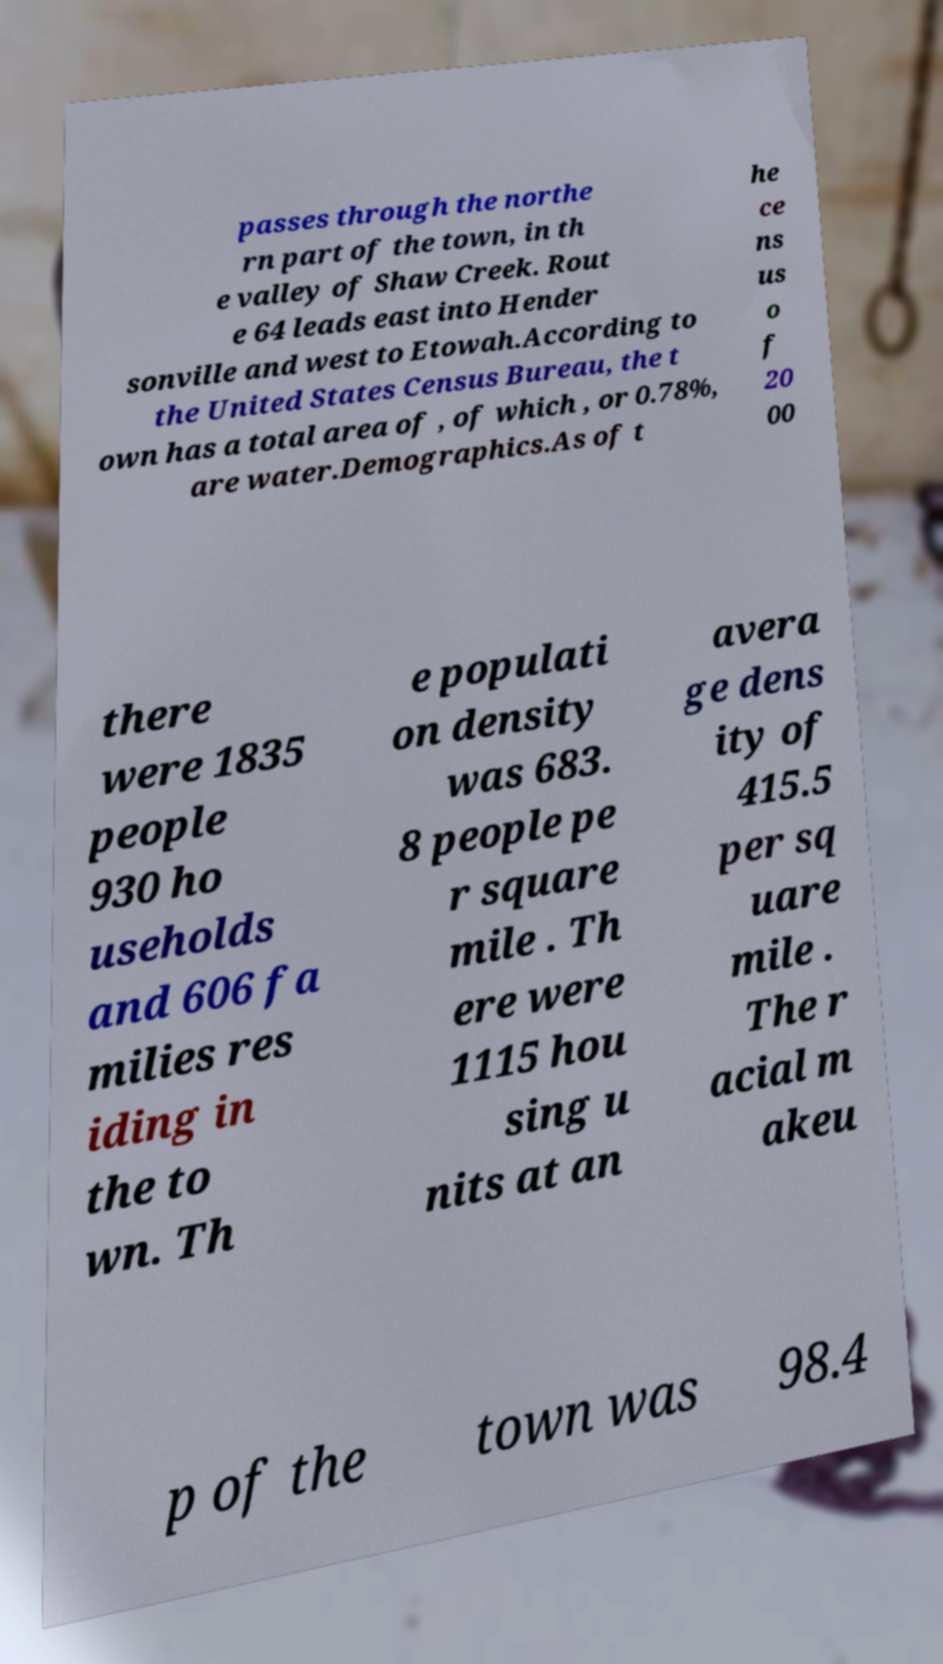Please identify and transcribe the text found in this image. passes through the northe rn part of the town, in th e valley of Shaw Creek. Rout e 64 leads east into Hender sonville and west to Etowah.According to the United States Census Bureau, the t own has a total area of , of which , or 0.78%, are water.Demographics.As of t he ce ns us o f 20 00 there were 1835 people 930 ho useholds and 606 fa milies res iding in the to wn. Th e populati on density was 683. 8 people pe r square mile . Th ere were 1115 hou sing u nits at an avera ge dens ity of 415.5 per sq uare mile . The r acial m akeu p of the town was 98.4 